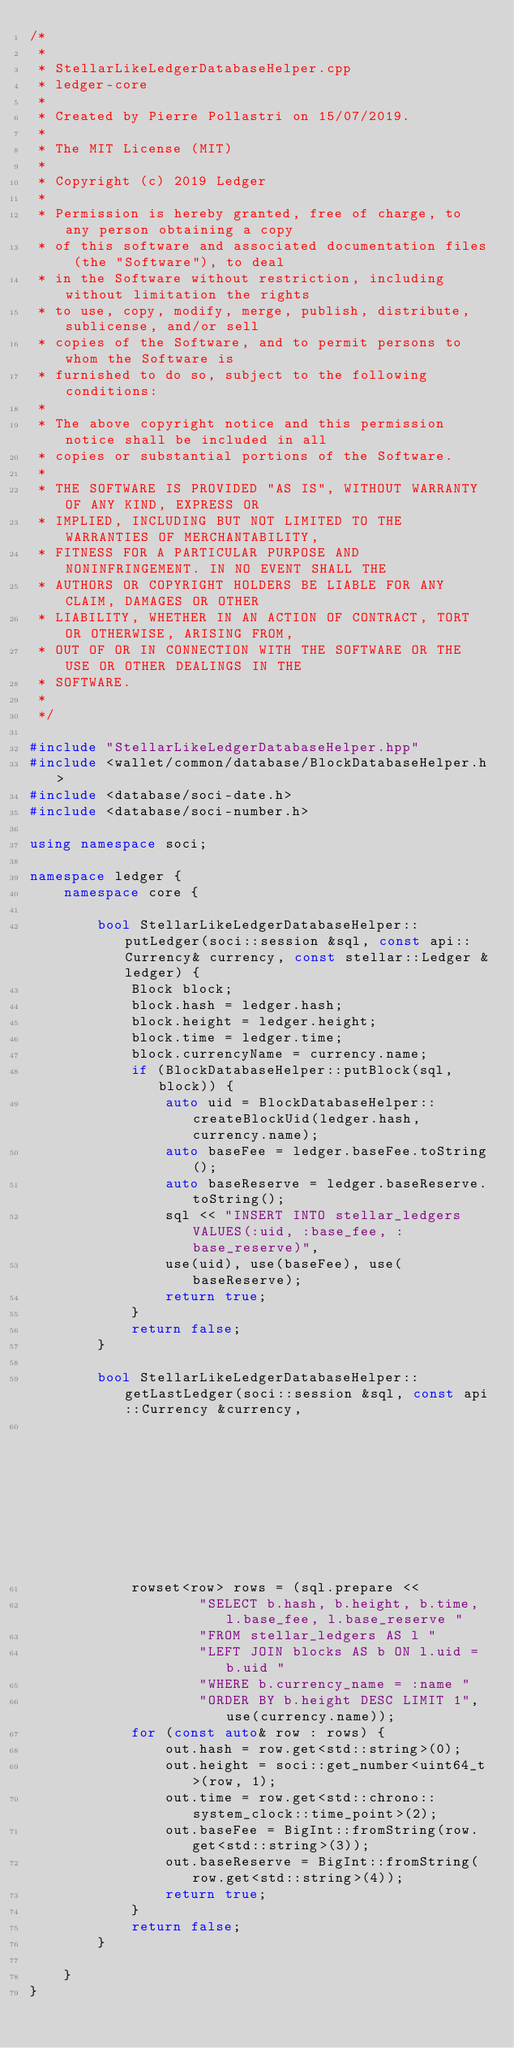Convert code to text. <code><loc_0><loc_0><loc_500><loc_500><_C++_>/*
 *
 * StellarLikeLedgerDatabaseHelper.cpp
 * ledger-core
 *
 * Created by Pierre Pollastri on 15/07/2019.
 *
 * The MIT License (MIT)
 *
 * Copyright (c) 2019 Ledger
 *
 * Permission is hereby granted, free of charge, to any person obtaining a copy
 * of this software and associated documentation files (the "Software"), to deal
 * in the Software without restriction, including without limitation the rights
 * to use, copy, modify, merge, publish, distribute, sublicense, and/or sell
 * copies of the Software, and to permit persons to whom the Software is
 * furnished to do so, subject to the following conditions:
 *
 * The above copyright notice and this permission notice shall be included in all
 * copies or substantial portions of the Software.
 *
 * THE SOFTWARE IS PROVIDED "AS IS", WITHOUT WARRANTY OF ANY KIND, EXPRESS OR
 * IMPLIED, INCLUDING BUT NOT LIMITED TO THE WARRANTIES OF MERCHANTABILITY,
 * FITNESS FOR A PARTICULAR PURPOSE AND NONINFRINGEMENT. IN NO EVENT SHALL THE
 * AUTHORS OR COPYRIGHT HOLDERS BE LIABLE FOR ANY CLAIM, DAMAGES OR OTHER
 * LIABILITY, WHETHER IN AN ACTION OF CONTRACT, TORT OR OTHERWISE, ARISING FROM,
 * OUT OF OR IN CONNECTION WITH THE SOFTWARE OR THE USE OR OTHER DEALINGS IN THE
 * SOFTWARE.
 *
 */

#include "StellarLikeLedgerDatabaseHelper.hpp"
#include <wallet/common/database/BlockDatabaseHelper.h>
#include <database/soci-date.h>
#include <database/soci-number.h>

using namespace soci;

namespace ledger {
    namespace core {

        bool StellarLikeLedgerDatabaseHelper::putLedger(soci::session &sql, const api::Currency& currency, const stellar::Ledger &ledger) {
            Block block;
            block.hash = ledger.hash;
            block.height = ledger.height;
            block.time = ledger.time;
            block.currencyName = currency.name;
            if (BlockDatabaseHelper::putBlock(sql, block)) {
                auto uid = BlockDatabaseHelper::createBlockUid(ledger.hash, currency.name);
                auto baseFee = ledger.baseFee.toString();
                auto baseReserve = ledger.baseReserve.toString();
                sql << "INSERT INTO stellar_ledgers VALUES(:uid, :base_fee, :base_reserve)",
                use(uid), use(baseFee), use(baseReserve);
                return true;
            }
            return false;
        }

        bool StellarLikeLedgerDatabaseHelper::getLastLedger(soci::session &sql, const api::Currency &currency,
                                                            stellar::Ledger &out) {
            rowset<row> rows = (sql.prepare <<
                    "SELECT b.hash, b.height, b.time, l.base_fee, l.base_reserve "
                    "FROM stellar_ledgers AS l "
                    "LEFT JOIN blocks AS b ON l.uid = b.uid "
                    "WHERE b.currency_name = :name "
                    "ORDER BY b.height DESC LIMIT 1", use(currency.name));
            for (const auto& row : rows) {
                out.hash = row.get<std::string>(0);
                out.height = soci::get_number<uint64_t>(row, 1);
                out.time = row.get<std::chrono::system_clock::time_point>(2);
                out.baseFee = BigInt::fromString(row.get<std::string>(3));
                out.baseReserve = BigInt::fromString(row.get<std::string>(4));
                return true;
            }
            return false;
        }

    }
}</code> 